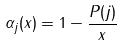<formula> <loc_0><loc_0><loc_500><loc_500>\alpha _ { j } ( x ) = 1 - \frac { P ( j ) } { x }</formula> 